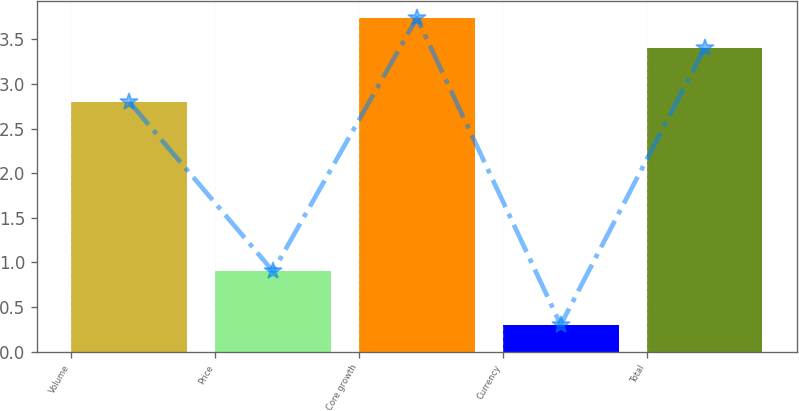<chart> <loc_0><loc_0><loc_500><loc_500><bar_chart><fcel>Volume<fcel>Price<fcel>Core growth<fcel>Currency<fcel>Total<nl><fcel>2.8<fcel>0.9<fcel>3.74<fcel>0.3<fcel>3.4<nl></chart> 